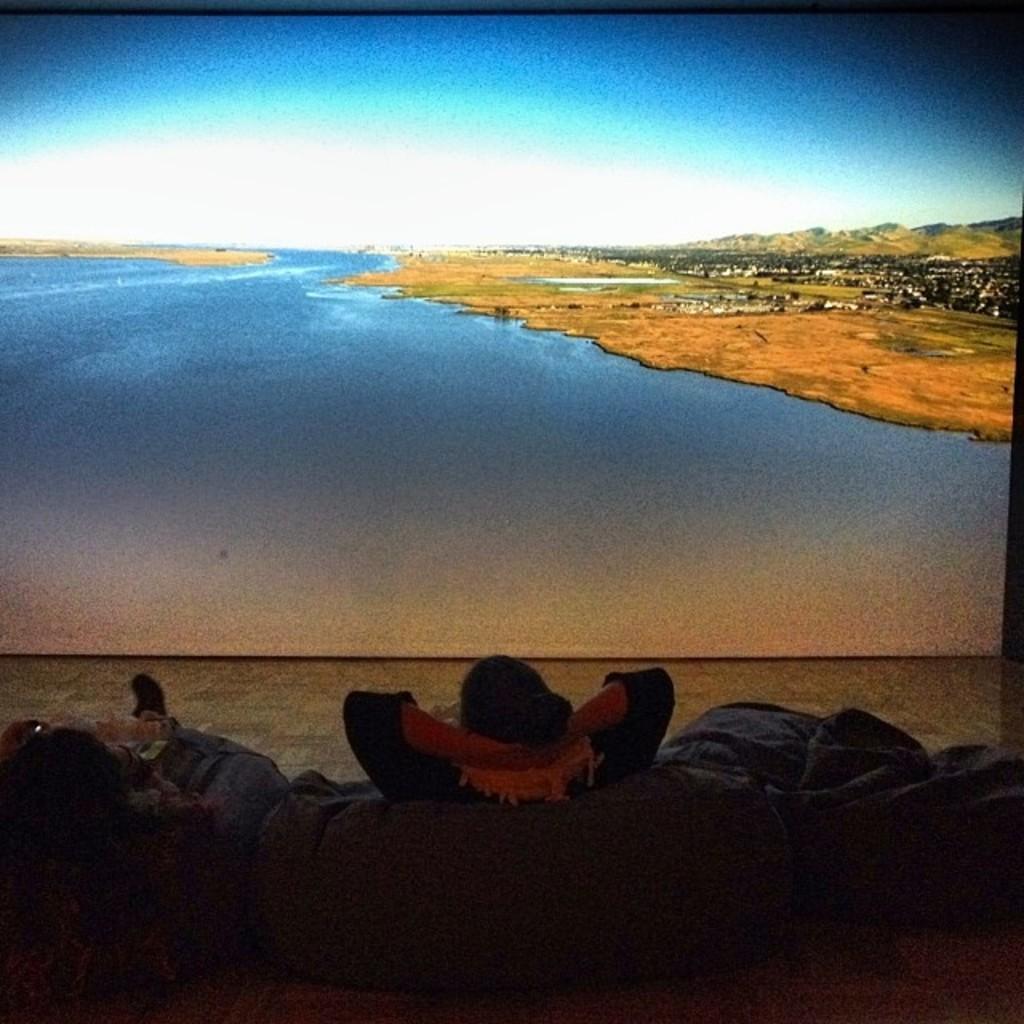Could you give a brief overview of what you see in this image? In this picture we can see two people sitting on bean bags and in front of them we can see a screen and on this screen we can see mountains, river and the sky. 